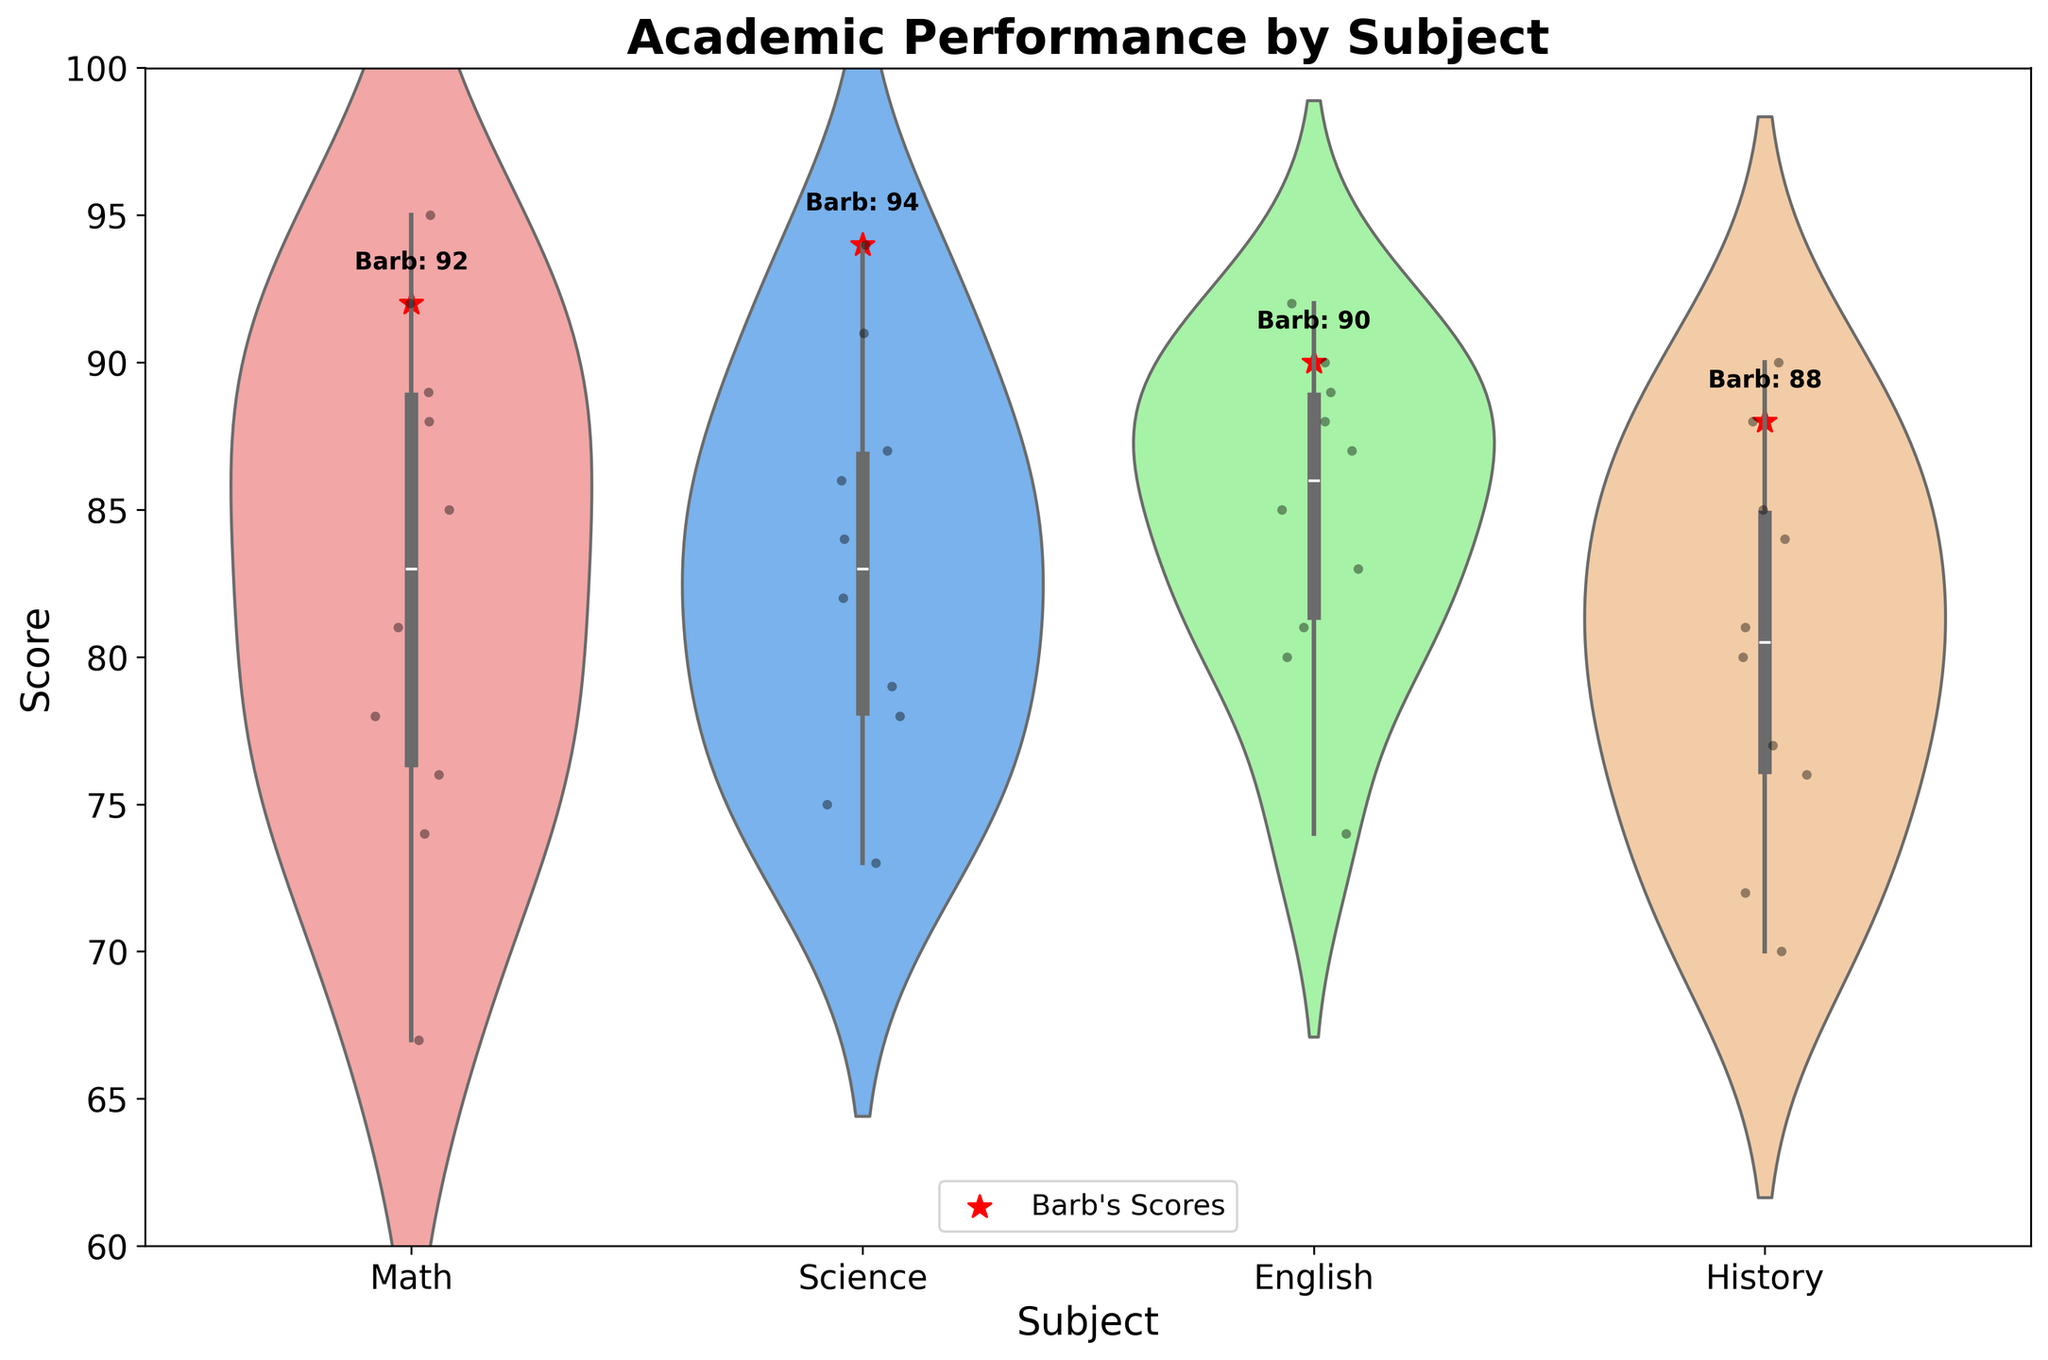What's the title of the plot? The title can be found at the top of the plot, it reads "Academic Performance by Subject".
Answer: Academic Performance by Subject What subjects are shown in the plot? The x-axis labels represent the subjects which are displayed in the plot; they are Math, Science, English, and History.
Answer: Math, Science, English, History What is the range of scores shown on the y-axis? The y-axis displays the range of possible scores from 60 to 100.
Answer: 60 to 100 How many students scored in Math? Each violin plot shows the total number of data points, and the Math plot has 10 individual black points indicating 10 students.
Answer: 10 What is the median score for students in Science? The box plot within the Science violin plot shows the median as the line inside the box. The median score line appears around 84.
Answer: 84 Which subject did Barb score the highest in? Barb's scores are highlighted with red stars, and the highest among them is in Science at 94.
Answer: Science How do the interquartile ranges (IQR) of Math and English compare? The IQR can be found between the top and bottom edges of the boxes within the violin plots. Math's IQR appears wider than that of English, indicating more variation in scores.
Answer: Math's IQR is wider Do any students have scores below 70, and if so, in which subject(s)? Checking the individual data points below 70 in the violin plots, we see scores below 70 in Math and History (Brian with scores 67 and 70, respectively).
Answer: Math and History Compare the mean scores between Math and English. While the plot does not show mean scores explicitly, the general trend can be observed. Math's peak density is lower than English, suggesting higher mean scores in English.
Answer: English has a higher mean score In which subject is the spread of scores the narrowest? The narrowest spread can be observed in the violin plot where the width of the violin is the smallest, indicating less variability; this is seen in English.
Answer: English What score did Barb achieve in History? Barb’s score in History is highlighted with a red star and annotated; she scored 88.
Answer: 88 